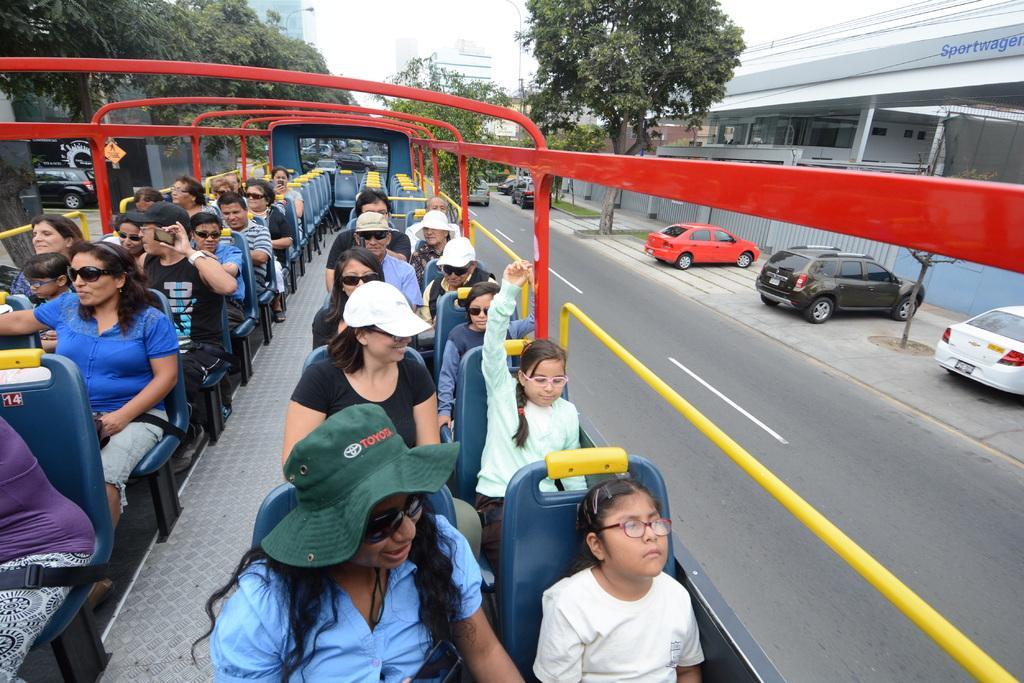In one or two sentences, can you explain what this image depicts? In this image we can see that there are so many people sitting in the seats in the vehicle. The vehicle is on the road. On the right side there is a footpath on which there are few cars parked beside the trees. On the right side top it is a building. In the background there are trees and buildings. 